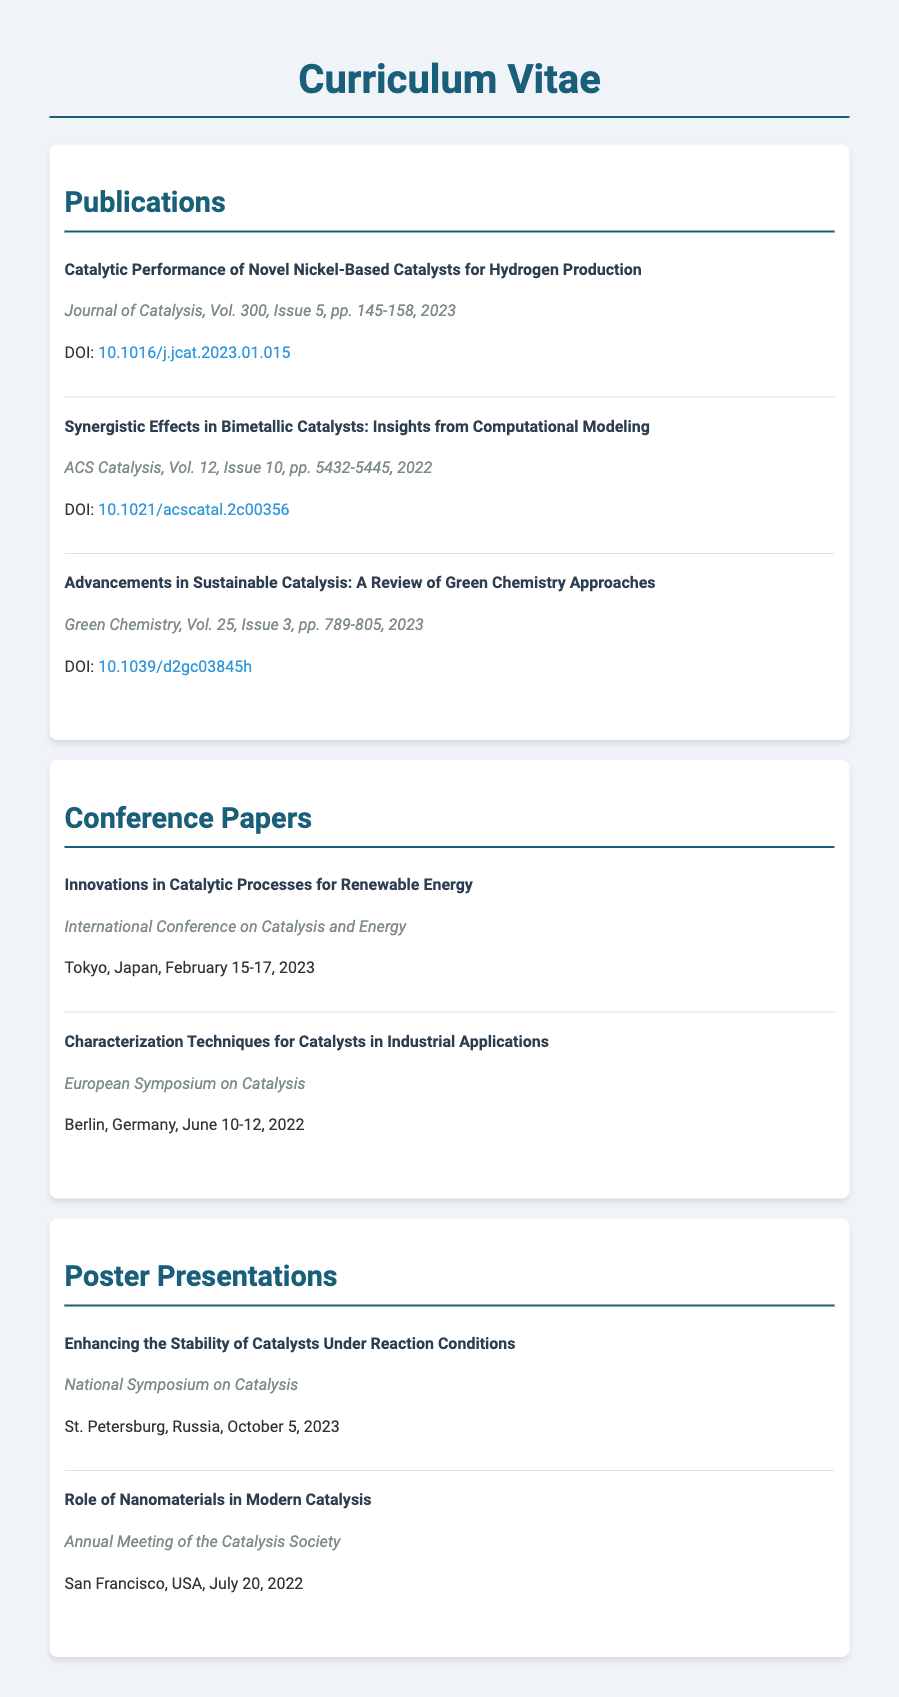what is the title of the most recent publication? The most recent publication listed is the one titled "Catalytic Performance of Novel Nickel-Based Catalysts for Hydrogen Production."
Answer: Catalytic Performance of Novel Nickel-Based Catalysts for Hydrogen Production how many publications are listed in total? The document lists a total of three publications.
Answer: 3 which journal published the article on green chemistry approaches? The article on green chemistry approaches is published in "Green Chemistry."
Answer: Green Chemistry when was the conference in Tokyo held? The conference in Tokyo was held from February 15-17, 2023.
Answer: February 15-17, 2023 who presented a poster on enhancing the stability of catalysts? The document does not specify a presenter’s name for the poster on enhancing the stability of catalysts.
Answer: Not specified which city hosted the recent poster presentation? The recent poster presentation took place in St. Petersburg, Russia.
Answer: St. Petersburg, Russia what is the volume and issue of the publication in ACS Catalysis? The volume and issue of the publication in ACS Catalysis is Vol. 12, Issue 10.
Answer: Vol. 12, Issue 10 how many conference papers are listed? The document lists a total of two conference papers.
Answer: 2 what is the topic of the poster presented at the Annual Meeting of the Catalysis Society? The topic of the poster at the Annual Meeting of the Catalysis Society is "Role of Nanomaterials in Modern Catalysis."
Answer: Role of Nanomaterials in Modern Catalysis 